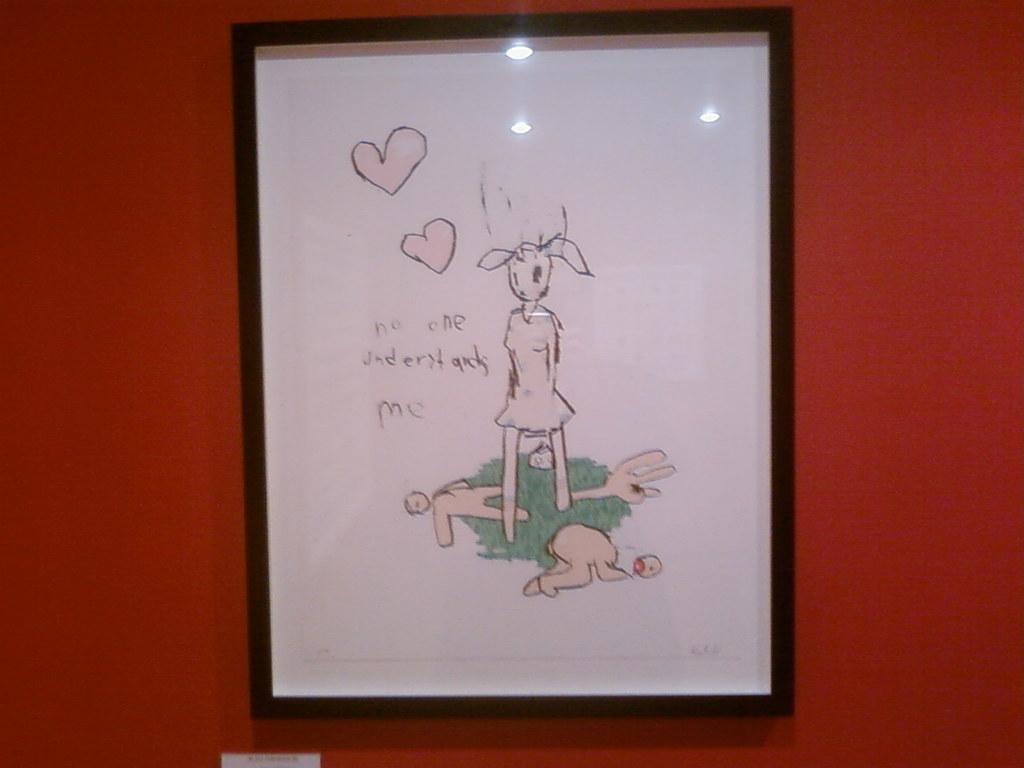<image>
Summarize the visual content of the image. A framed drawing says, "no on understands me" is hung on a red wall. 